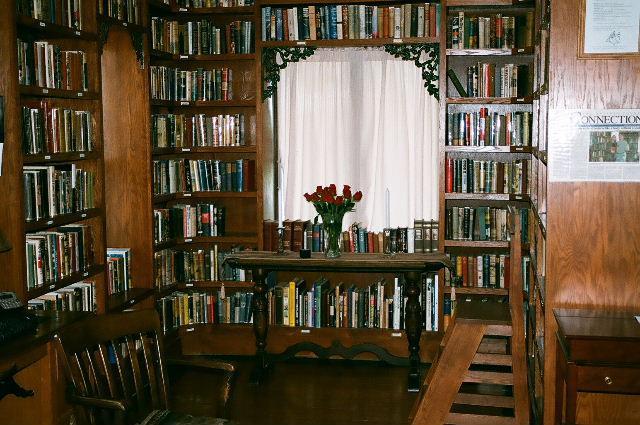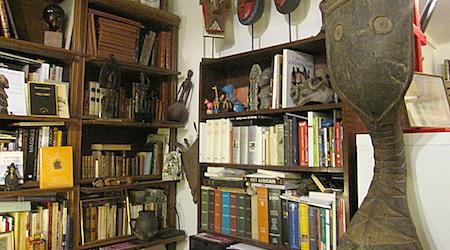The first image is the image on the left, the second image is the image on the right. Evaluate the accuracy of this statement regarding the images: "One image shows the exterior of a book shop.". Is it true? Answer yes or no. No. The first image is the image on the left, the second image is the image on the right. Examine the images to the left and right. Is the description "One of the images shows the outside of a bookstore." accurate? Answer yes or no. No. 